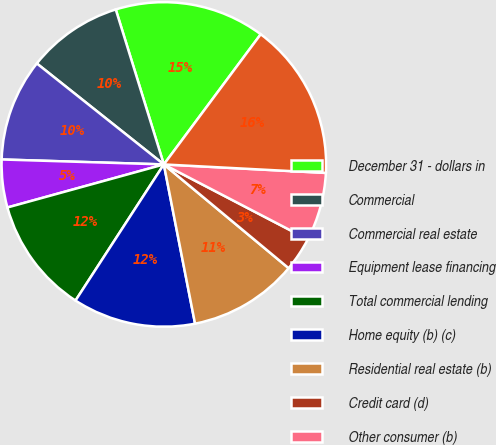Convert chart to OTSL. <chart><loc_0><loc_0><loc_500><loc_500><pie_chart><fcel>December 31 - dollars in<fcel>Commercial<fcel>Commercial real estate<fcel>Equipment lease financing<fcel>Total commercial lending<fcel>Home equity (b) (c)<fcel>Residential real estate (b)<fcel>Credit card (d)<fcel>Other consumer (b)<fcel>Total consumer lending (e)<nl><fcel>14.97%<fcel>9.52%<fcel>10.2%<fcel>4.76%<fcel>11.56%<fcel>12.24%<fcel>10.88%<fcel>3.4%<fcel>6.8%<fcel>15.65%<nl></chart> 